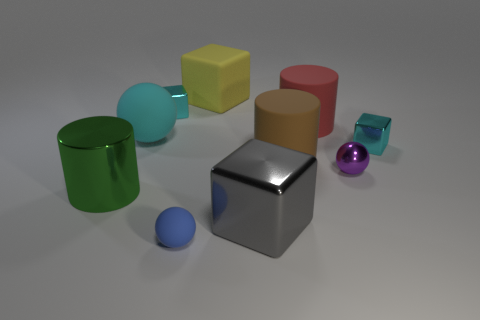The small shiny object that is right of the tiny purple shiny ball has what shape?
Your response must be concise. Cube. How many other objects are the same size as the yellow matte cube?
Offer a very short reply. 5. Does the tiny shiny thing behind the big red thing have the same shape as the big metallic thing on the right side of the large rubber block?
Keep it short and to the point. Yes. How many small cubes are right of the matte cube?
Provide a succinct answer. 1. There is a big object that is in front of the large shiny cylinder; what color is it?
Give a very brief answer. Gray. What color is the other large metallic object that is the same shape as the big yellow thing?
Offer a terse response. Gray. Are there any other things of the same color as the big ball?
Your response must be concise. Yes. Is the number of matte blocks greater than the number of small things?
Give a very brief answer. No. Is the material of the purple ball the same as the large green cylinder?
Make the answer very short. Yes. What number of gray things have the same material as the red object?
Your response must be concise. 0. 